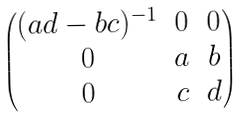<formula> <loc_0><loc_0><loc_500><loc_500>\begin{pmatrix} ( a d - b c ) ^ { - 1 } & 0 & 0 \\ 0 & a & b \\ 0 & c & d \end{pmatrix}</formula> 